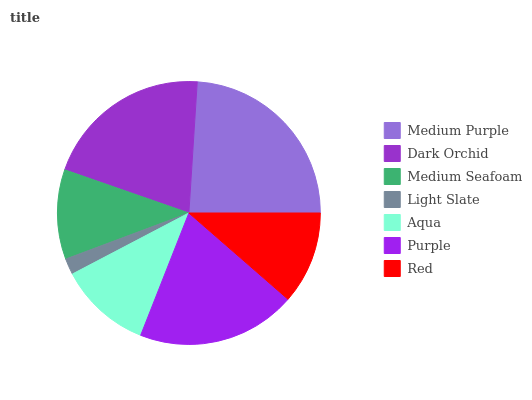Is Light Slate the minimum?
Answer yes or no. Yes. Is Medium Purple the maximum?
Answer yes or no. Yes. Is Dark Orchid the minimum?
Answer yes or no. No. Is Dark Orchid the maximum?
Answer yes or no. No. Is Medium Purple greater than Dark Orchid?
Answer yes or no. Yes. Is Dark Orchid less than Medium Purple?
Answer yes or no. Yes. Is Dark Orchid greater than Medium Purple?
Answer yes or no. No. Is Medium Purple less than Dark Orchid?
Answer yes or no. No. Is Red the high median?
Answer yes or no. Yes. Is Red the low median?
Answer yes or no. Yes. Is Medium Purple the high median?
Answer yes or no. No. Is Aqua the low median?
Answer yes or no. No. 